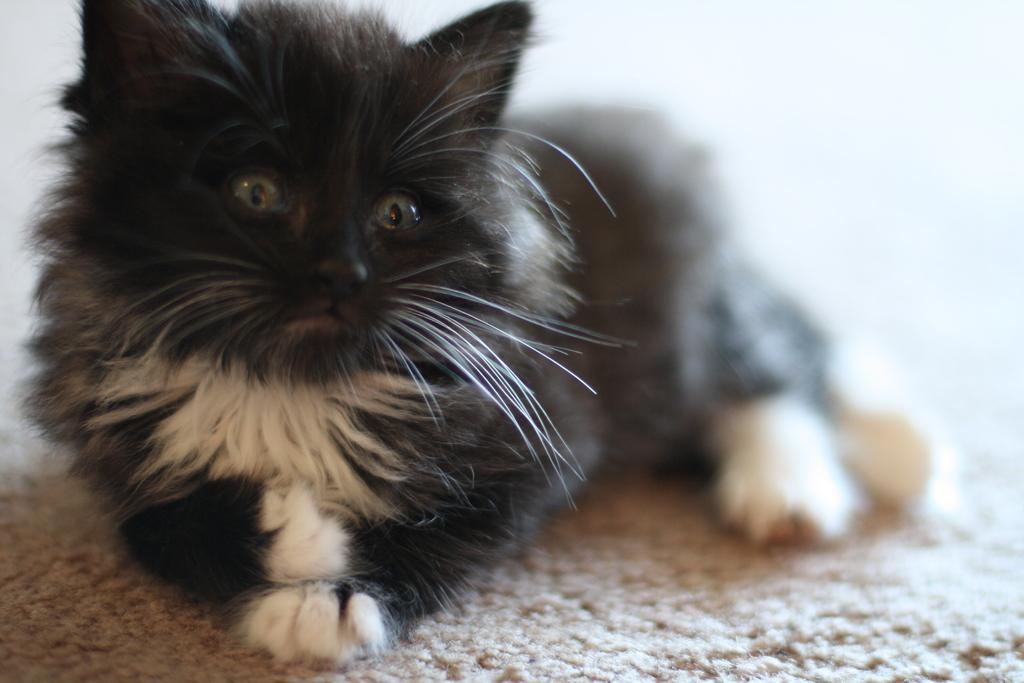What type of animal is in the image? There is a black color cat in the image. What is at the bottom of the image? There is a mat at the bottom of the image. What type of sock is the cat wearing on its front paw in the image? There is no sock visible on the cat's paw in the image. What is the cat pointing at with its paw in the image? The cat is not pointing at anything with its paw in the image. 